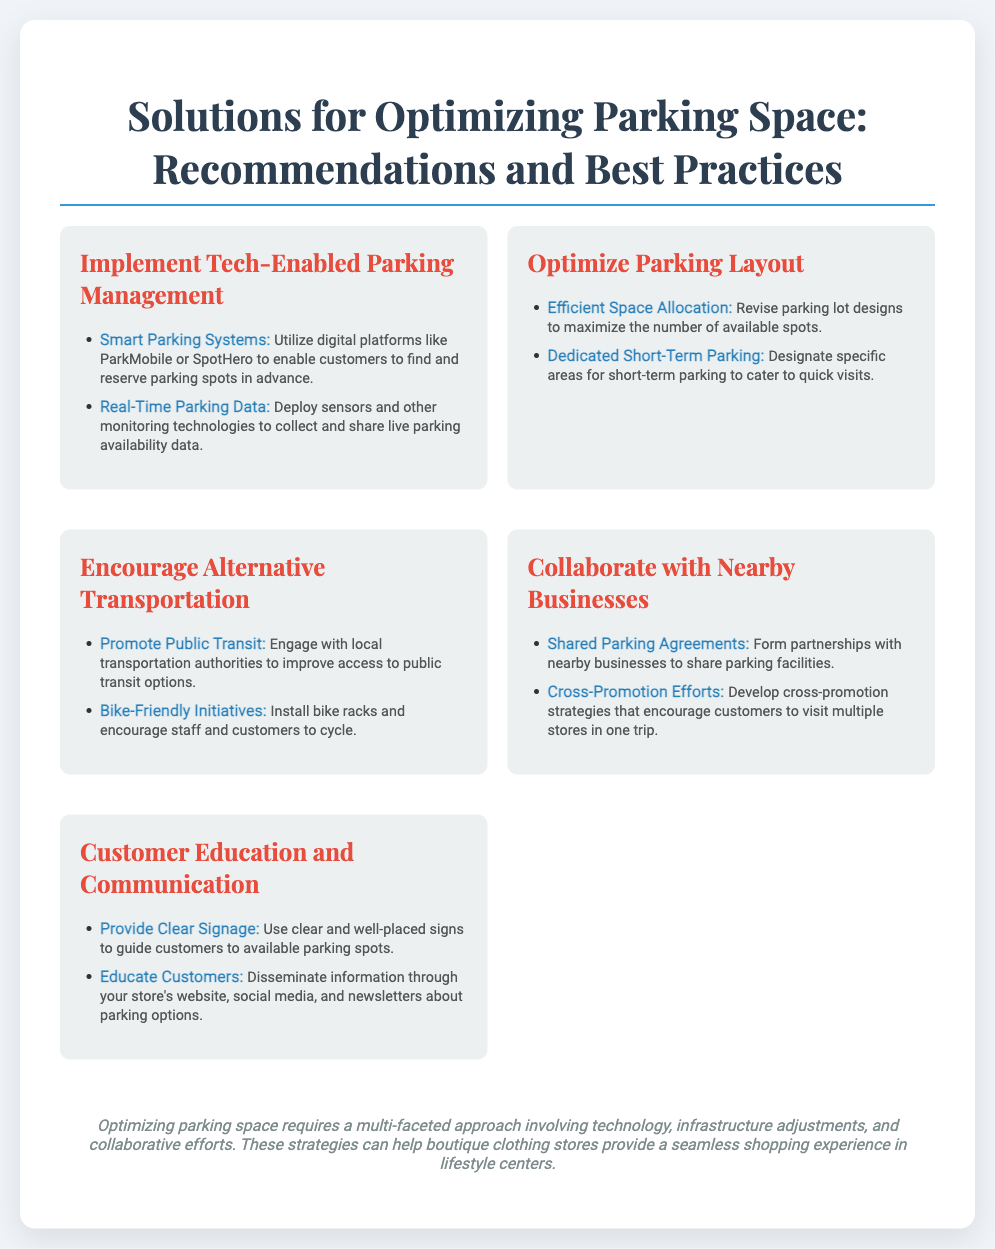what is a recommended tech-enabled solution for parking management? The document suggests utilizing digital platforms like ParkMobile or SpotHero.
Answer: digital platforms like ParkMobile or SpotHero what is one way to optimize parking layout? The document states that revising parking lot designs can maximize the number of available spots.
Answer: revise parking lot designs name one alternative transportation solution promoted in the document. One of the solutions mentioned is to engage with local transportation authorities for public transit.
Answer: public transit how can businesses collaborate to optimize parking space? The document recommends forming partnerships with nearby businesses to share parking facilities.
Answer: share parking facilities which strategy involves educating customers about parking options? The document suggests disseminating information through various channels such as social media or newsletters.
Answer: disseminating information what is a benefit of dedicated short-term parking? The document explains this parking caters to quick visits, enhancing customer satisfaction.
Answer: caters to quick visits 